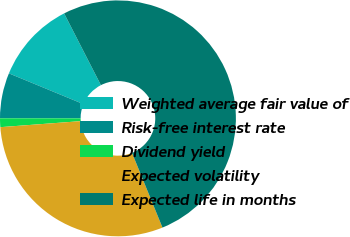Convert chart. <chart><loc_0><loc_0><loc_500><loc_500><pie_chart><fcel>Weighted average fair value of<fcel>Risk-free interest rate<fcel>Dividend yield<fcel>Expected volatility<fcel>Expected life in months<nl><fcel>11.23%<fcel>6.22%<fcel>1.2%<fcel>29.97%<fcel>51.38%<nl></chart> 